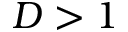Convert formula to latex. <formula><loc_0><loc_0><loc_500><loc_500>D > 1</formula> 